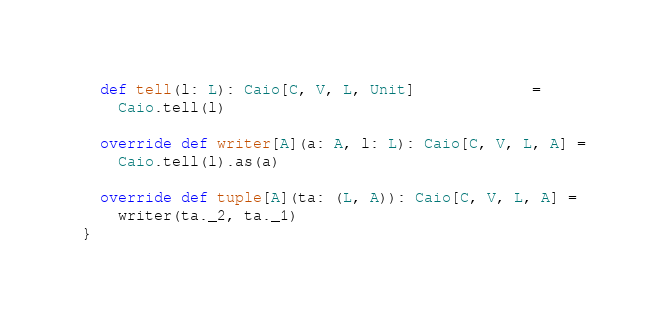Convert code to text. <code><loc_0><loc_0><loc_500><loc_500><_Scala_>
  def tell(l: L): Caio[C, V, L, Unit]             =
    Caio.tell(l)

  override def writer[A](a: A, l: L): Caio[C, V, L, A] =
    Caio.tell(l).as(a)

  override def tuple[A](ta: (L, A)): Caio[C, V, L, A] =
    writer(ta._2, ta._1)
}
</code> 